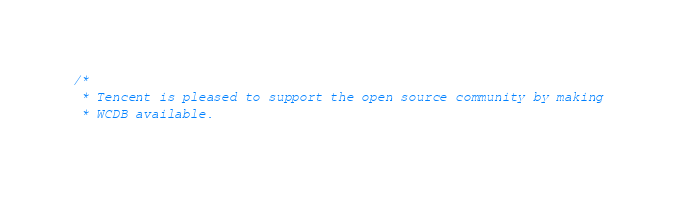Convert code to text. <code><loc_0><loc_0><loc_500><loc_500><_ObjectiveC_>/*
 * Tencent is pleased to support the open source community by making
 * WCDB available.</code> 